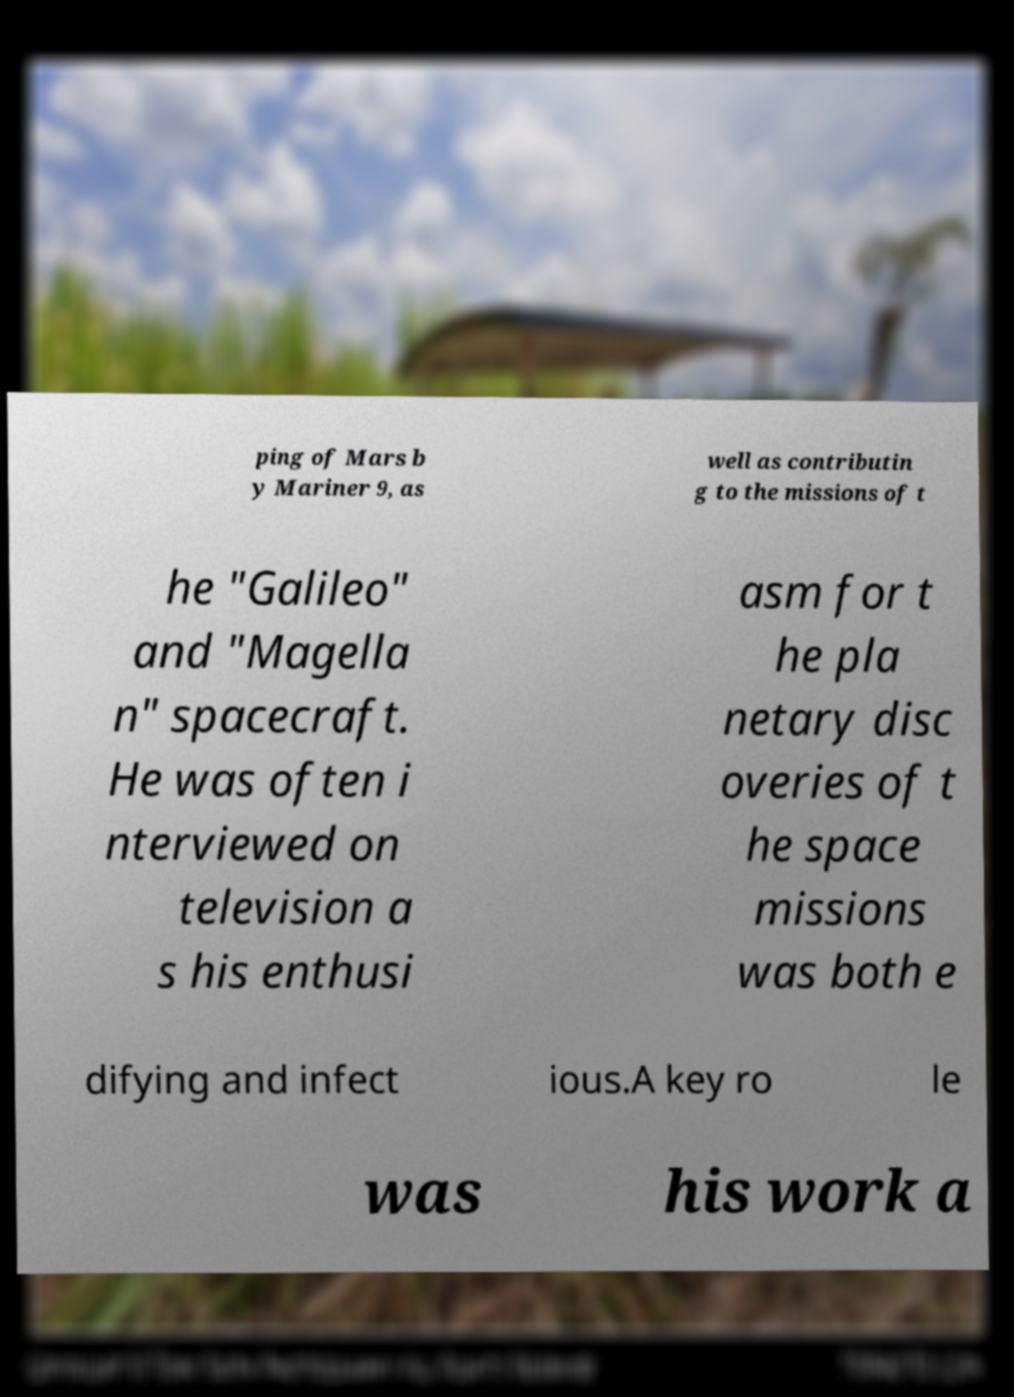Can you accurately transcribe the text from the provided image for me? ping of Mars b y Mariner 9, as well as contributin g to the missions of t he "Galileo" and "Magella n" spacecraft. He was often i nterviewed on television a s his enthusi asm for t he pla netary disc overies of t he space missions was both e difying and infect ious.A key ro le was his work a 